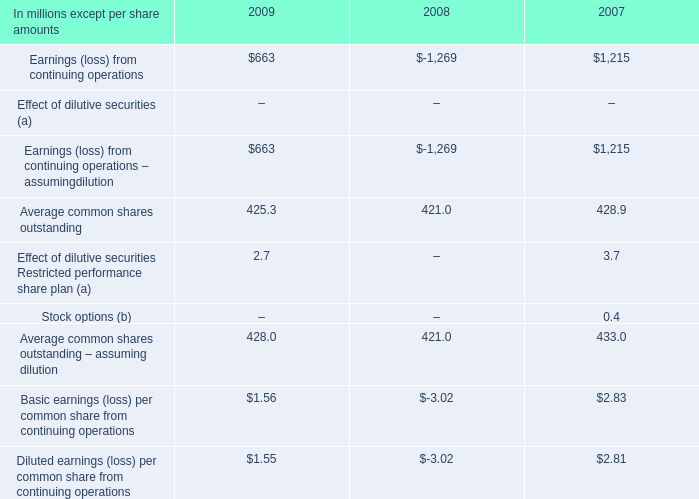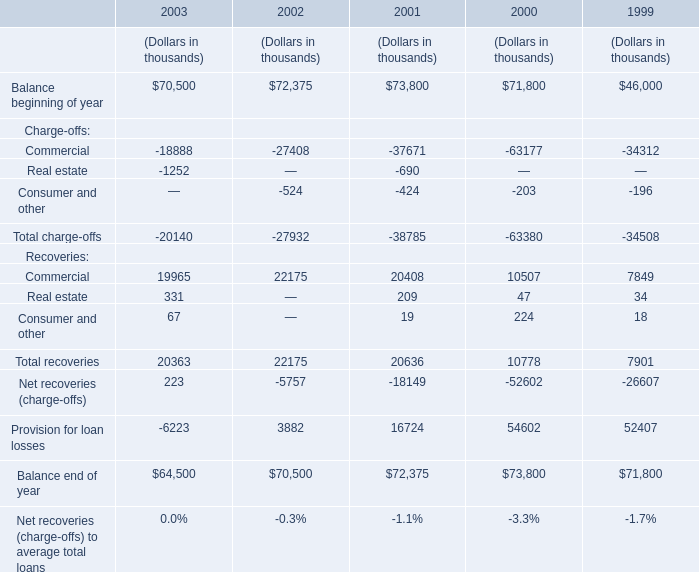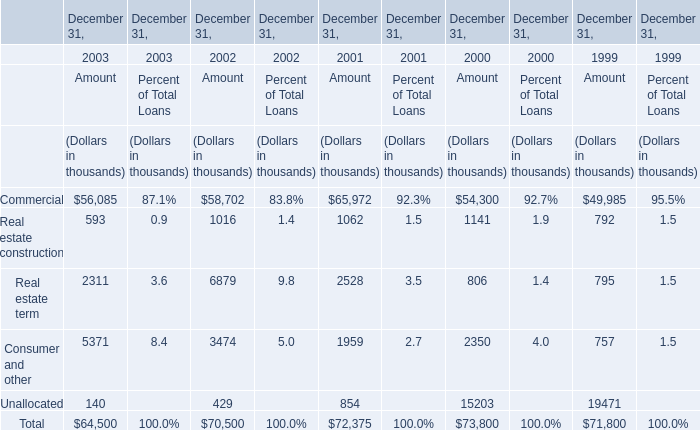What is the sum of the Real estate term for Amount in the years where Commercial for Amount is positive? (in thousand) 
Computations: ((((2311 + 6879) + 2528) + 806) + 795)
Answer: 13319.0. 